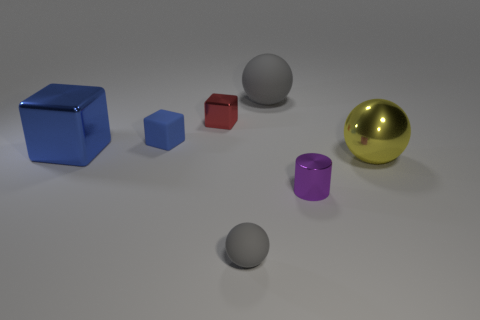Is the color of the big object in front of the big cube the same as the matte ball that is in front of the yellow shiny thing?
Offer a terse response. No. How many yellow things are shiny cubes or small spheres?
Provide a succinct answer. 0. Is the number of purple metallic objects that are behind the red object less than the number of objects that are in front of the small blue rubber object?
Offer a very short reply. Yes. Is there a yellow metal ball that has the same size as the blue matte thing?
Provide a short and direct response. No. Do the object right of the purple shiny thing and the large shiny cube have the same size?
Keep it short and to the point. Yes. Are there more spheres than big gray matte objects?
Give a very brief answer. Yes. Are there any other big things of the same shape as the large blue thing?
Your answer should be very brief. No. The thing that is to the right of the small metallic cylinder has what shape?
Your answer should be very brief. Sphere. There is a gray ball that is on the right side of the gray matte object that is in front of the small blue cube; how many gray objects are to the left of it?
Keep it short and to the point. 1. Is the color of the metallic thing that is on the right side of the small purple metallic object the same as the large block?
Offer a very short reply. No. 